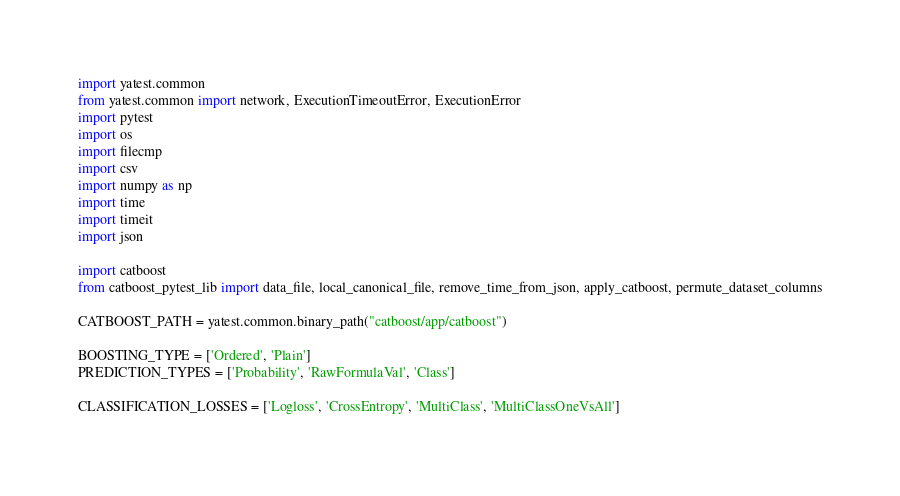<code> <loc_0><loc_0><loc_500><loc_500><_Python_>import yatest.common
from yatest.common import network, ExecutionTimeoutError, ExecutionError
import pytest
import os
import filecmp
import csv
import numpy as np
import time
import timeit
import json

import catboost
from catboost_pytest_lib import data_file, local_canonical_file, remove_time_from_json, apply_catboost, permute_dataset_columns

CATBOOST_PATH = yatest.common.binary_path("catboost/app/catboost")

BOOSTING_TYPE = ['Ordered', 'Plain']
PREDICTION_TYPES = ['Probability', 'RawFormulaVal', 'Class']

CLASSIFICATION_LOSSES = ['Logloss', 'CrossEntropy', 'MultiClass', 'MultiClassOneVsAll']</code> 